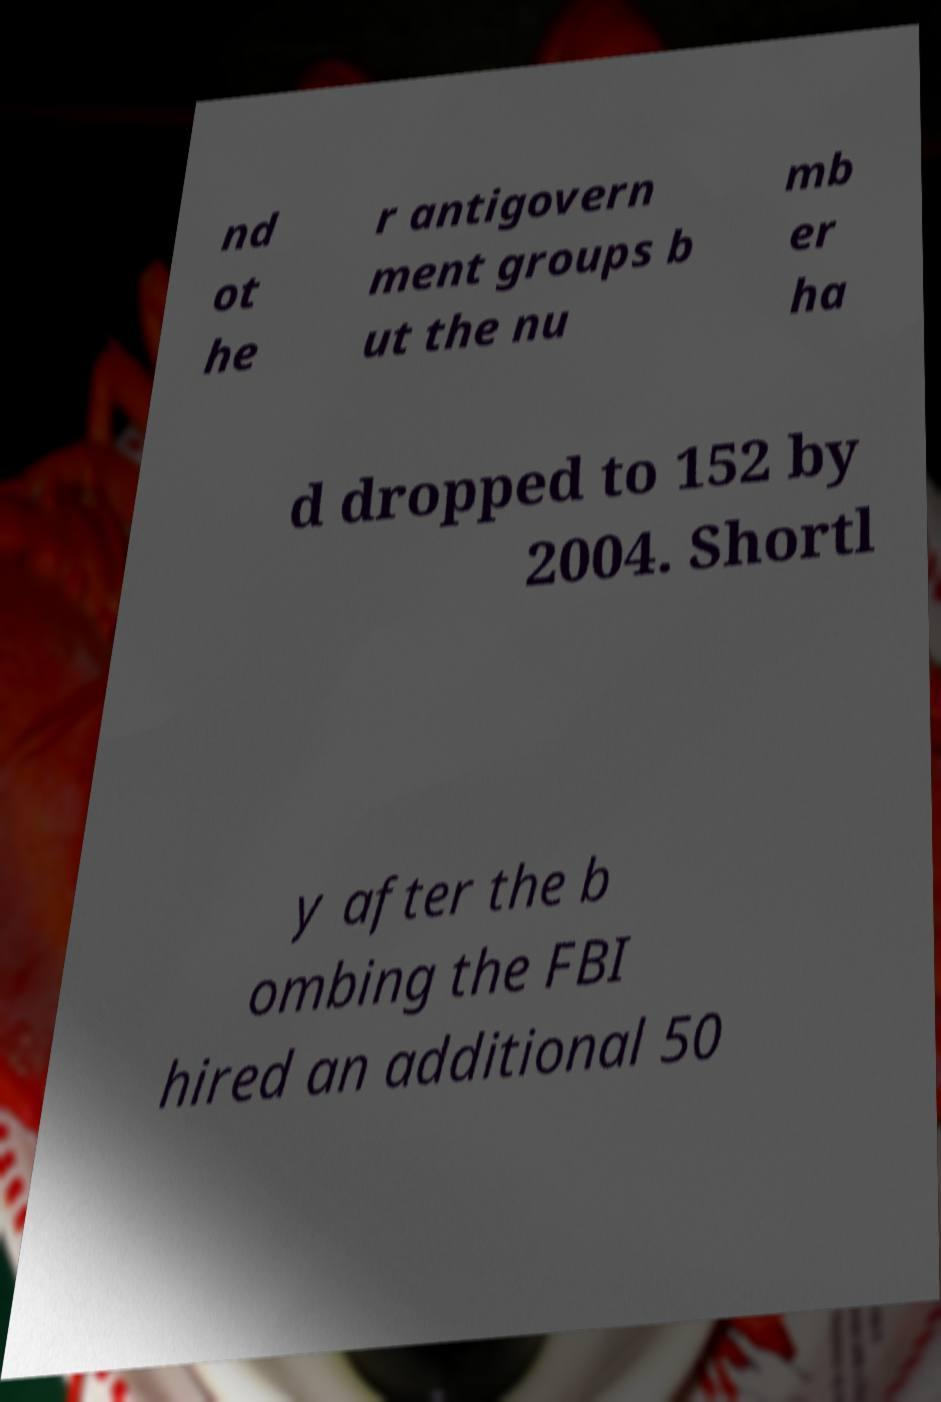Please read and relay the text visible in this image. What does it say? nd ot he r antigovern ment groups b ut the nu mb er ha d dropped to 152 by 2004. Shortl y after the b ombing the FBI hired an additional 50 